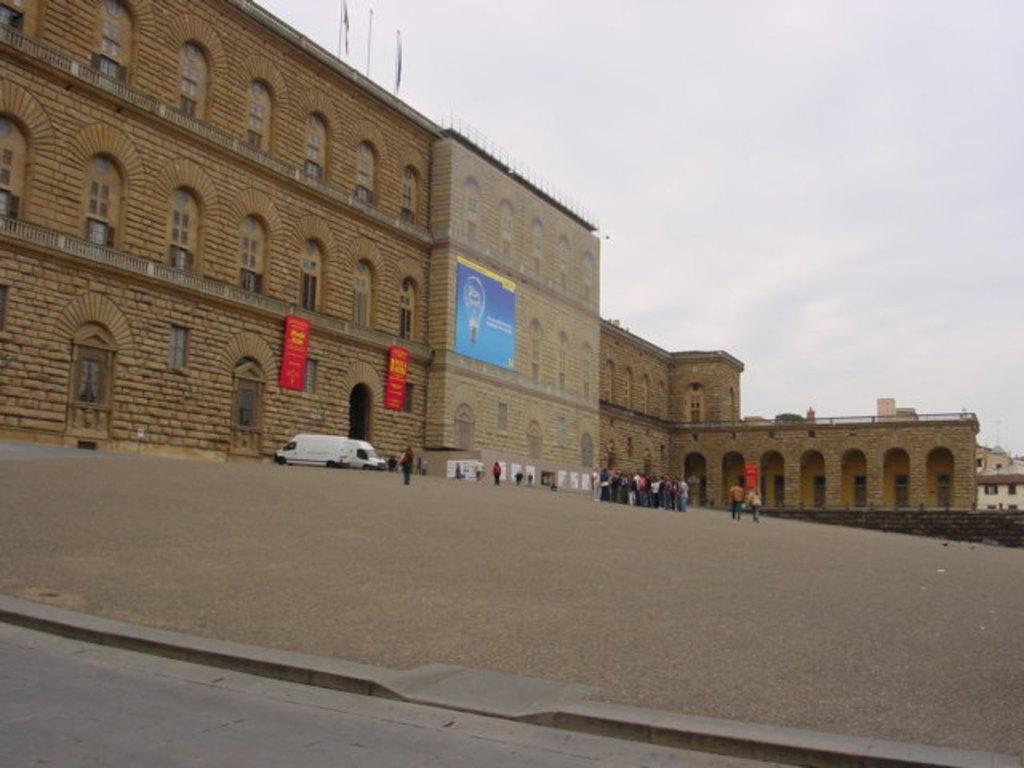Could you give a brief overview of what you see in this image? In this image I can see few buildings, ground and on it I can see number of people are standing. I can also see few vehicles on the ground and on the building I can see few boards. I can also see something is written on these boards and in the background I can see clouds and the sky. On the top side of this image I can see few flags on the building. 